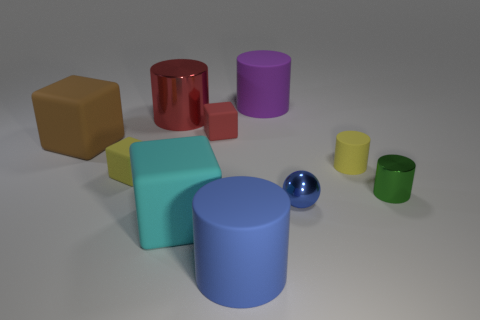Is the number of red shiny things that are in front of the red shiny cylinder the same as the number of small cyan matte cylinders?
Provide a succinct answer. Yes. Is the material of the red thing in front of the big red object the same as the block in front of the green metallic object?
Make the answer very short. Yes. There is a tiny red thing that is in front of the large purple rubber cylinder; is its shape the same as the small object to the left of the red block?
Ensure brevity in your answer.  Yes. Is the number of cylinders behind the blue metal object less than the number of small red rubber things?
Provide a short and direct response. No. What number of big metallic cylinders are the same color as the big shiny thing?
Your answer should be compact. 0. There is a block behind the large brown thing; how big is it?
Offer a very short reply. Small. The yellow object in front of the small yellow matte object that is on the right side of the yellow rubber object that is left of the purple cylinder is what shape?
Make the answer very short. Cube. The big rubber object that is behind the blue ball and in front of the big purple cylinder has what shape?
Offer a very short reply. Cube. Is there a rubber cylinder of the same size as the yellow rubber block?
Make the answer very short. Yes. There is a shiny thing that is behind the green object; is its shape the same as the tiny green shiny thing?
Provide a short and direct response. Yes. 